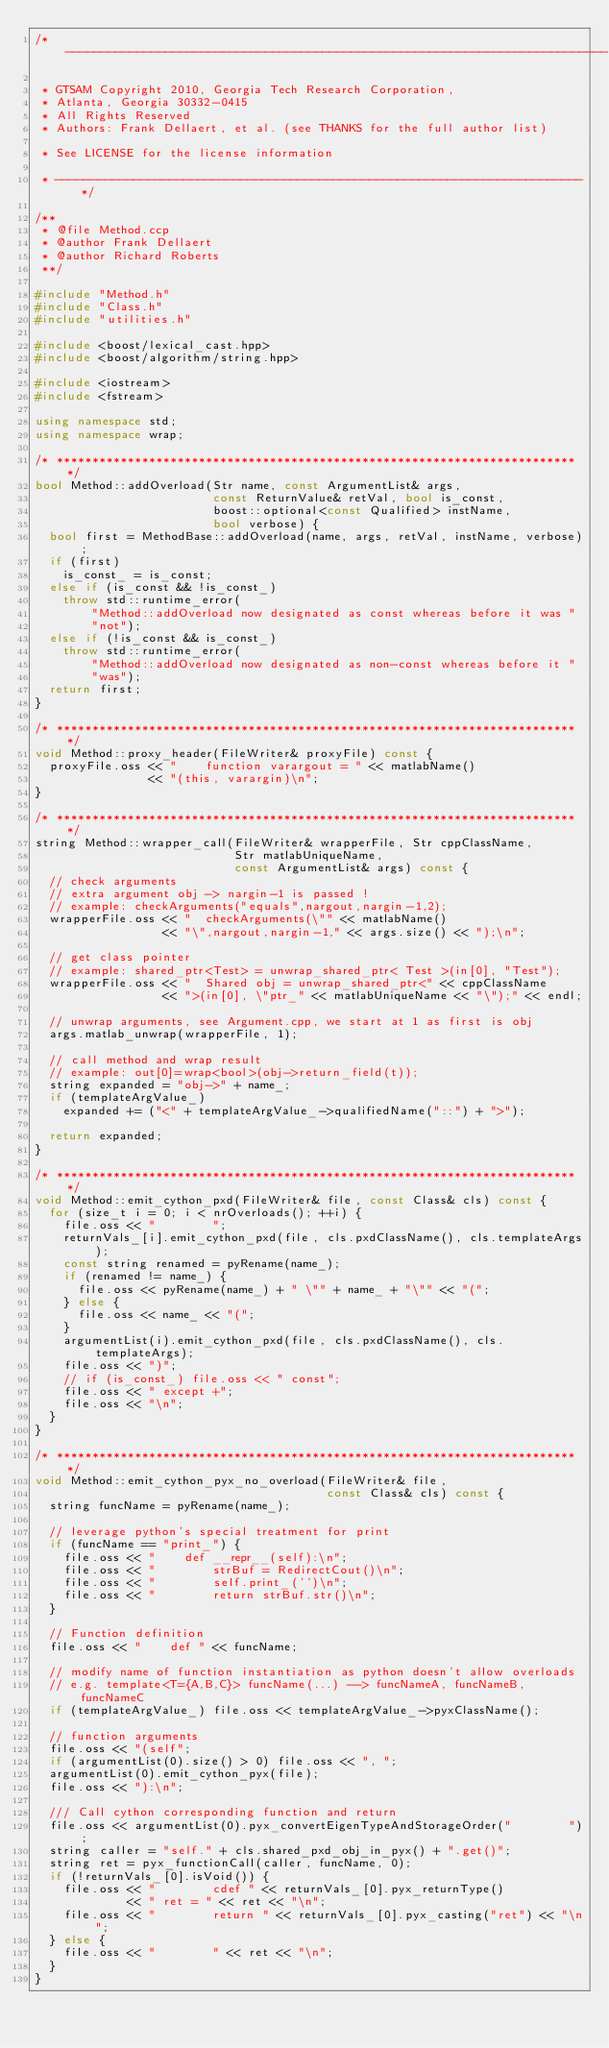<code> <loc_0><loc_0><loc_500><loc_500><_C++_>/* ----------------------------------------------------------------------------

 * GTSAM Copyright 2010, Georgia Tech Research Corporation,
 * Atlanta, Georgia 30332-0415
 * All Rights Reserved
 * Authors: Frank Dellaert, et al. (see THANKS for the full author list)

 * See LICENSE for the license information

 * -------------------------------------------------------------------------- */

/**
 * @file Method.ccp
 * @author Frank Dellaert
 * @author Richard Roberts
 **/

#include "Method.h"
#include "Class.h"
#include "utilities.h"

#include <boost/lexical_cast.hpp>
#include <boost/algorithm/string.hpp>

#include <iostream>
#include <fstream>

using namespace std;
using namespace wrap;

/* ************************************************************************* */
bool Method::addOverload(Str name, const ArgumentList& args,
                         const ReturnValue& retVal, bool is_const,
                         boost::optional<const Qualified> instName,
                         bool verbose) {
  bool first = MethodBase::addOverload(name, args, retVal, instName, verbose);
  if (first)
    is_const_ = is_const;
  else if (is_const && !is_const_)
    throw std::runtime_error(
        "Method::addOverload now designated as const whereas before it was "
        "not");
  else if (!is_const && is_const_)
    throw std::runtime_error(
        "Method::addOverload now designated as non-const whereas before it "
        "was");
  return first;
}

/* ************************************************************************* */
void Method::proxy_header(FileWriter& proxyFile) const {
  proxyFile.oss << "    function varargout = " << matlabName()
                << "(this, varargin)\n";
}

/* ************************************************************************* */
string Method::wrapper_call(FileWriter& wrapperFile, Str cppClassName,
                            Str matlabUniqueName,
                            const ArgumentList& args) const {
  // check arguments
  // extra argument obj -> nargin-1 is passed !
  // example: checkArguments("equals",nargout,nargin-1,2);
  wrapperFile.oss << "  checkArguments(\"" << matlabName()
                  << "\",nargout,nargin-1," << args.size() << ");\n";

  // get class pointer
  // example: shared_ptr<Test> = unwrap_shared_ptr< Test >(in[0], "Test");
  wrapperFile.oss << "  Shared obj = unwrap_shared_ptr<" << cppClassName
                  << ">(in[0], \"ptr_" << matlabUniqueName << "\");" << endl;

  // unwrap arguments, see Argument.cpp, we start at 1 as first is obj
  args.matlab_unwrap(wrapperFile, 1);

  // call method and wrap result
  // example: out[0]=wrap<bool>(obj->return_field(t));
  string expanded = "obj->" + name_;
  if (templateArgValue_)
    expanded += ("<" + templateArgValue_->qualifiedName("::") + ">");

  return expanded;
}

/* ************************************************************************* */
void Method::emit_cython_pxd(FileWriter& file, const Class& cls) const {
  for (size_t i = 0; i < nrOverloads(); ++i) {
    file.oss << "        ";
    returnVals_[i].emit_cython_pxd(file, cls.pxdClassName(), cls.templateArgs);
    const string renamed = pyRename(name_);
    if (renamed != name_) {
      file.oss << pyRename(name_) + " \"" + name_ + "\"" << "(";
    } else {
      file.oss << name_ << "(";
    }
    argumentList(i).emit_cython_pxd(file, cls.pxdClassName(), cls.templateArgs);
    file.oss << ")";
    // if (is_const_) file.oss << " const";
    file.oss << " except +";
    file.oss << "\n";
  }
}

/* ************************************************************************* */
void Method::emit_cython_pyx_no_overload(FileWriter& file,
                                         const Class& cls) const {
  string funcName = pyRename(name_);

  // leverage python's special treatment for print
  if (funcName == "print_") {
    file.oss << "    def __repr__(self):\n";
    file.oss << "        strBuf = RedirectCout()\n";
    file.oss << "        self.print_('')\n";
    file.oss << "        return strBuf.str()\n";
  }

  // Function definition
  file.oss << "    def " << funcName;

  // modify name of function instantiation as python doesn't allow overloads
  // e.g. template<T={A,B,C}> funcName(...) --> funcNameA, funcNameB, funcNameC
  if (templateArgValue_) file.oss << templateArgValue_->pyxClassName();

  // function arguments
  file.oss << "(self";
  if (argumentList(0).size() > 0) file.oss << ", ";
  argumentList(0).emit_cython_pyx(file);
  file.oss << "):\n";

  /// Call cython corresponding function and return
  file.oss << argumentList(0).pyx_convertEigenTypeAndStorageOrder("        ");
  string caller = "self." + cls.shared_pxd_obj_in_pyx() + ".get()";
  string ret = pyx_functionCall(caller, funcName, 0);
  if (!returnVals_[0].isVoid()) {
    file.oss << "        cdef " << returnVals_[0].pyx_returnType()
             << " ret = " << ret << "\n";
    file.oss << "        return " << returnVals_[0].pyx_casting("ret") << "\n";
  } else {
    file.oss << "        " << ret << "\n";
  }
}
</code> 